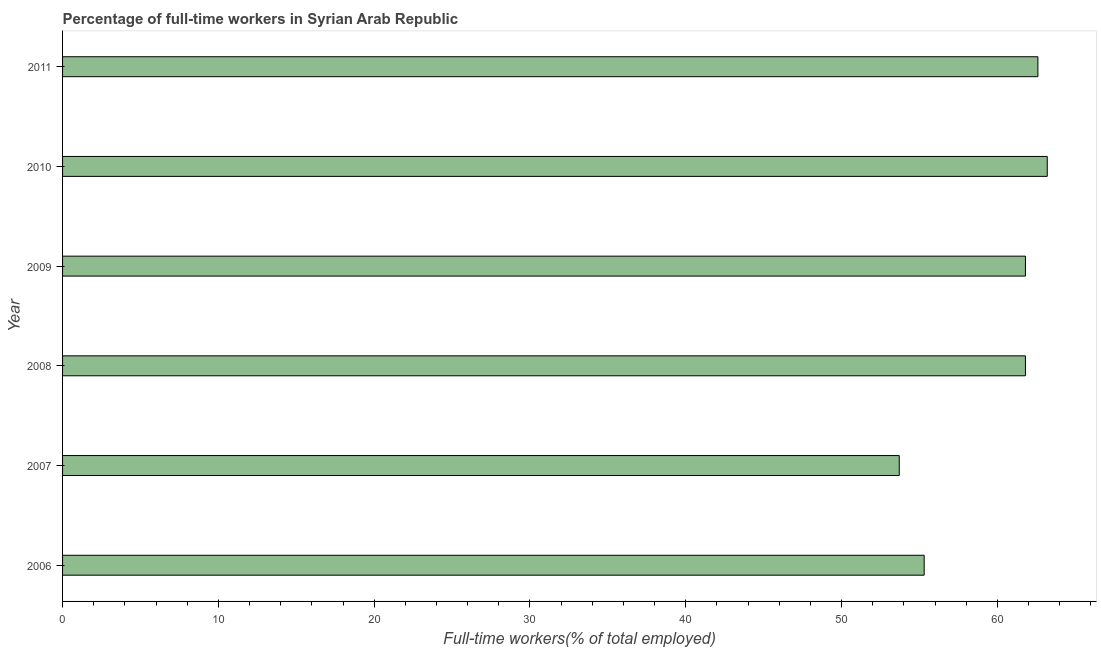What is the title of the graph?
Your answer should be compact. Percentage of full-time workers in Syrian Arab Republic. What is the label or title of the X-axis?
Provide a succinct answer. Full-time workers(% of total employed). What is the percentage of full-time workers in 2010?
Offer a very short reply. 63.2. Across all years, what is the maximum percentage of full-time workers?
Offer a terse response. 63.2. Across all years, what is the minimum percentage of full-time workers?
Offer a terse response. 53.7. In which year was the percentage of full-time workers minimum?
Provide a short and direct response. 2007. What is the sum of the percentage of full-time workers?
Keep it short and to the point. 358.4. What is the average percentage of full-time workers per year?
Your response must be concise. 59.73. What is the median percentage of full-time workers?
Ensure brevity in your answer.  61.8. Do a majority of the years between 2009 and 2011 (inclusive) have percentage of full-time workers greater than 18 %?
Keep it short and to the point. Yes. What is the ratio of the percentage of full-time workers in 2006 to that in 2007?
Your answer should be very brief. 1.03. Is the percentage of full-time workers in 2007 less than that in 2008?
Provide a succinct answer. Yes. Is the difference between the percentage of full-time workers in 2006 and 2011 greater than the difference between any two years?
Give a very brief answer. No. What is the difference between the highest and the second highest percentage of full-time workers?
Keep it short and to the point. 0.6. Is the sum of the percentage of full-time workers in 2006 and 2007 greater than the maximum percentage of full-time workers across all years?
Provide a short and direct response. Yes. What is the difference between the highest and the lowest percentage of full-time workers?
Offer a terse response. 9.5. In how many years, is the percentage of full-time workers greater than the average percentage of full-time workers taken over all years?
Give a very brief answer. 4. Are all the bars in the graph horizontal?
Provide a short and direct response. Yes. How many years are there in the graph?
Provide a succinct answer. 6. What is the difference between two consecutive major ticks on the X-axis?
Your answer should be compact. 10. Are the values on the major ticks of X-axis written in scientific E-notation?
Provide a short and direct response. No. What is the Full-time workers(% of total employed) of 2006?
Your answer should be compact. 55.3. What is the Full-time workers(% of total employed) of 2007?
Offer a terse response. 53.7. What is the Full-time workers(% of total employed) in 2008?
Make the answer very short. 61.8. What is the Full-time workers(% of total employed) of 2009?
Ensure brevity in your answer.  61.8. What is the Full-time workers(% of total employed) in 2010?
Offer a very short reply. 63.2. What is the Full-time workers(% of total employed) in 2011?
Make the answer very short. 62.6. What is the difference between the Full-time workers(% of total employed) in 2006 and 2007?
Ensure brevity in your answer.  1.6. What is the difference between the Full-time workers(% of total employed) in 2006 and 2008?
Provide a short and direct response. -6.5. What is the difference between the Full-time workers(% of total employed) in 2006 and 2010?
Keep it short and to the point. -7.9. What is the difference between the Full-time workers(% of total employed) in 2006 and 2011?
Ensure brevity in your answer.  -7.3. What is the difference between the Full-time workers(% of total employed) in 2007 and 2009?
Keep it short and to the point. -8.1. What is the difference between the Full-time workers(% of total employed) in 2007 and 2010?
Keep it short and to the point. -9.5. What is the difference between the Full-time workers(% of total employed) in 2007 and 2011?
Provide a short and direct response. -8.9. What is the difference between the Full-time workers(% of total employed) in 2008 and 2009?
Offer a very short reply. 0. What is the difference between the Full-time workers(% of total employed) in 2009 and 2011?
Make the answer very short. -0.8. What is the ratio of the Full-time workers(% of total employed) in 2006 to that in 2008?
Ensure brevity in your answer.  0.9. What is the ratio of the Full-time workers(% of total employed) in 2006 to that in 2009?
Your response must be concise. 0.9. What is the ratio of the Full-time workers(% of total employed) in 2006 to that in 2010?
Your answer should be very brief. 0.88. What is the ratio of the Full-time workers(% of total employed) in 2006 to that in 2011?
Keep it short and to the point. 0.88. What is the ratio of the Full-time workers(% of total employed) in 2007 to that in 2008?
Ensure brevity in your answer.  0.87. What is the ratio of the Full-time workers(% of total employed) in 2007 to that in 2009?
Make the answer very short. 0.87. What is the ratio of the Full-time workers(% of total employed) in 2007 to that in 2010?
Your answer should be very brief. 0.85. What is the ratio of the Full-time workers(% of total employed) in 2007 to that in 2011?
Ensure brevity in your answer.  0.86. What is the ratio of the Full-time workers(% of total employed) in 2008 to that in 2009?
Your answer should be very brief. 1. What is the ratio of the Full-time workers(% of total employed) in 2008 to that in 2011?
Keep it short and to the point. 0.99. What is the ratio of the Full-time workers(% of total employed) in 2010 to that in 2011?
Ensure brevity in your answer.  1.01. 